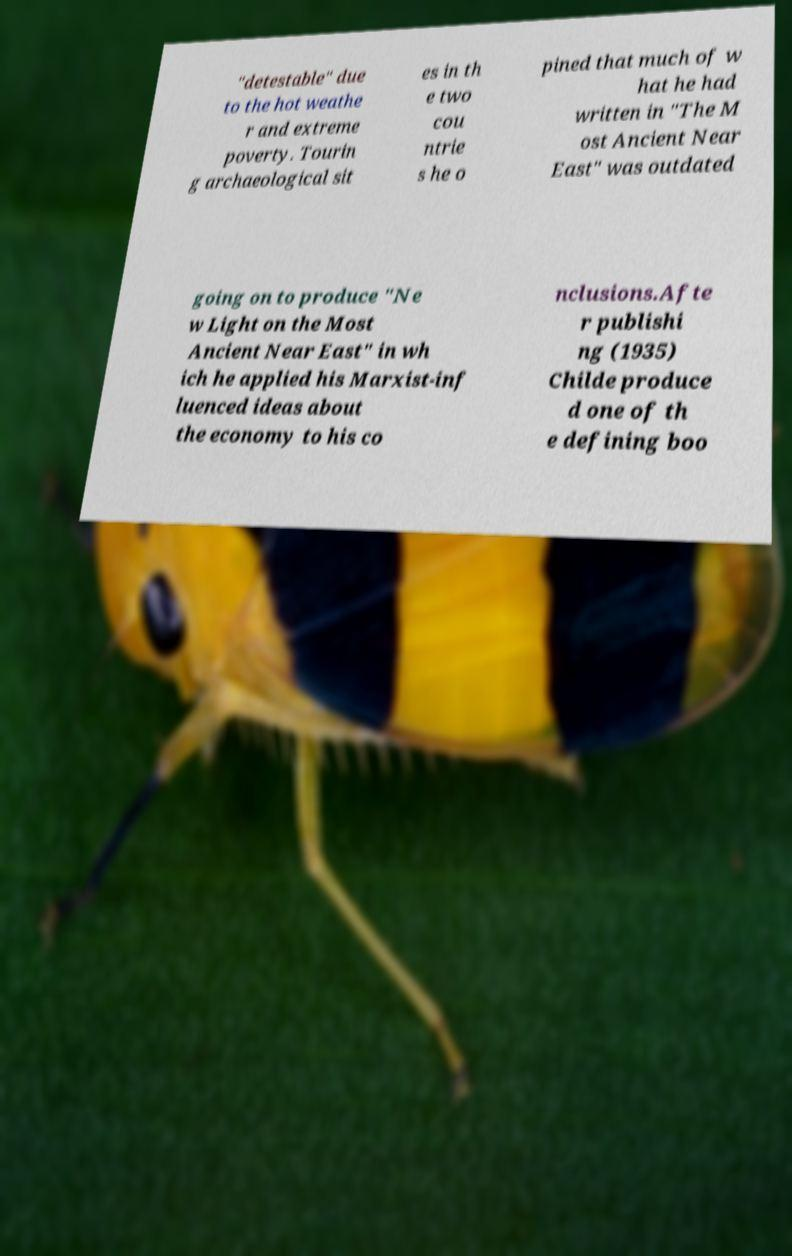Can you read and provide the text displayed in the image?This photo seems to have some interesting text. Can you extract and type it out for me? "detestable" due to the hot weathe r and extreme poverty. Tourin g archaeological sit es in th e two cou ntrie s he o pined that much of w hat he had written in "The M ost Ancient Near East" was outdated going on to produce "Ne w Light on the Most Ancient Near East" in wh ich he applied his Marxist-inf luenced ideas about the economy to his co nclusions.Afte r publishi ng (1935) Childe produce d one of th e defining boo 